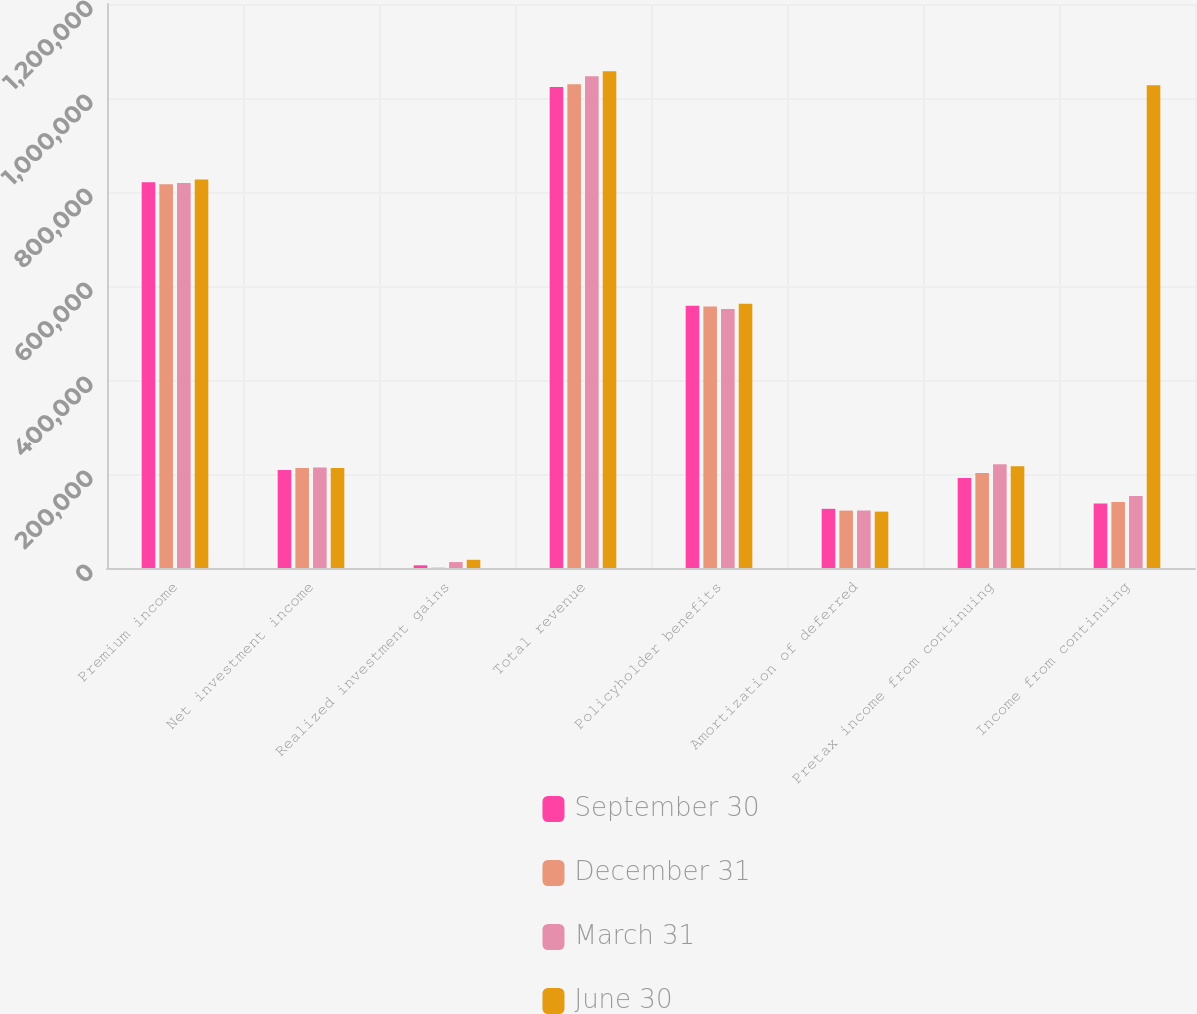Convert chart. <chart><loc_0><loc_0><loc_500><loc_500><stacked_bar_chart><ecel><fcel>Premium income<fcel>Net investment income<fcel>Realized investment gains<fcel>Total revenue<fcel>Policyholder benefits<fcel>Amortization of deferred<fcel>Pretax income from continuing<fcel>Income from continuing<nl><fcel>September 30<fcel>820631<fcel>208282<fcel>5748<fcel>1.02358e+06<fcel>557776<fcel>125908<fcel>191741<fcel>137178<nl><fcel>December 31<fcel>816614<fcel>212776<fcel>705<fcel>1.02908e+06<fcel>556415<fcel>122121<fcel>201926<fcel>140363<nl><fcel>March 31<fcel>819217<fcel>213872<fcel>12595<fcel>1.04602e+06<fcel>551219<fcel>122334<fcel>220610<fcel>153346<nl><fcel>June 30<fcel>826473<fcel>212955<fcel>17469<fcel>1.0569e+06<fcel>562465<fcel>120040<fcel>216371<fcel>1.02738e+06<nl></chart> 